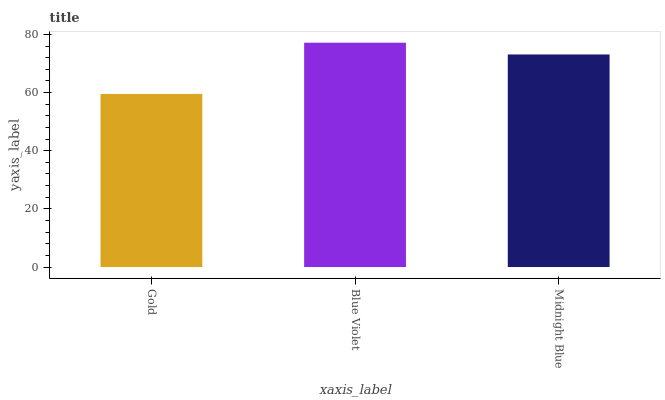Is Gold the minimum?
Answer yes or no. Yes. Is Blue Violet the maximum?
Answer yes or no. Yes. Is Midnight Blue the minimum?
Answer yes or no. No. Is Midnight Blue the maximum?
Answer yes or no. No. Is Blue Violet greater than Midnight Blue?
Answer yes or no. Yes. Is Midnight Blue less than Blue Violet?
Answer yes or no. Yes. Is Midnight Blue greater than Blue Violet?
Answer yes or no. No. Is Blue Violet less than Midnight Blue?
Answer yes or no. No. Is Midnight Blue the high median?
Answer yes or no. Yes. Is Midnight Blue the low median?
Answer yes or no. Yes. Is Blue Violet the high median?
Answer yes or no. No. Is Gold the low median?
Answer yes or no. No. 